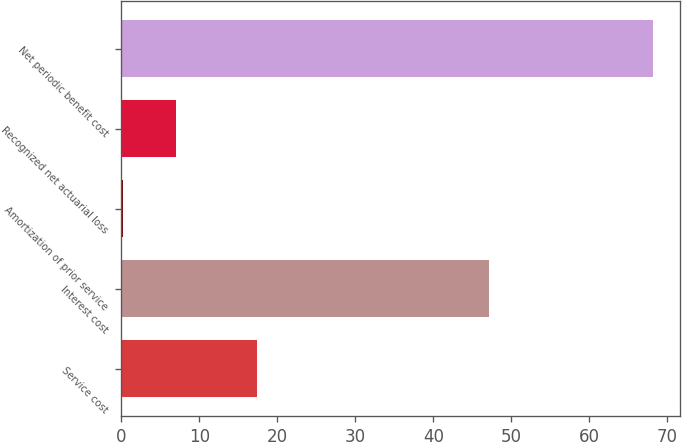Convert chart. <chart><loc_0><loc_0><loc_500><loc_500><bar_chart><fcel>Service cost<fcel>Interest cost<fcel>Amortization of prior service<fcel>Recognized net actuarial loss<fcel>Net periodic benefit cost<nl><fcel>17.4<fcel>47.1<fcel>0.2<fcel>7<fcel>68.2<nl></chart> 